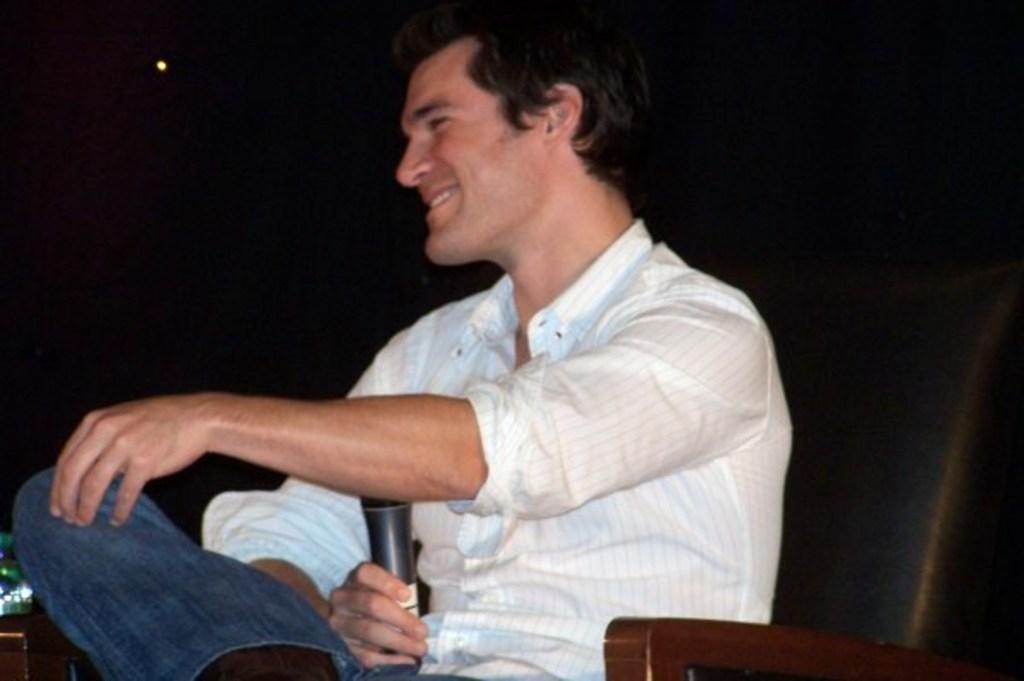Please provide a concise description of this image. This is the picture of a person in white shirt is holding the mic and sitting. 